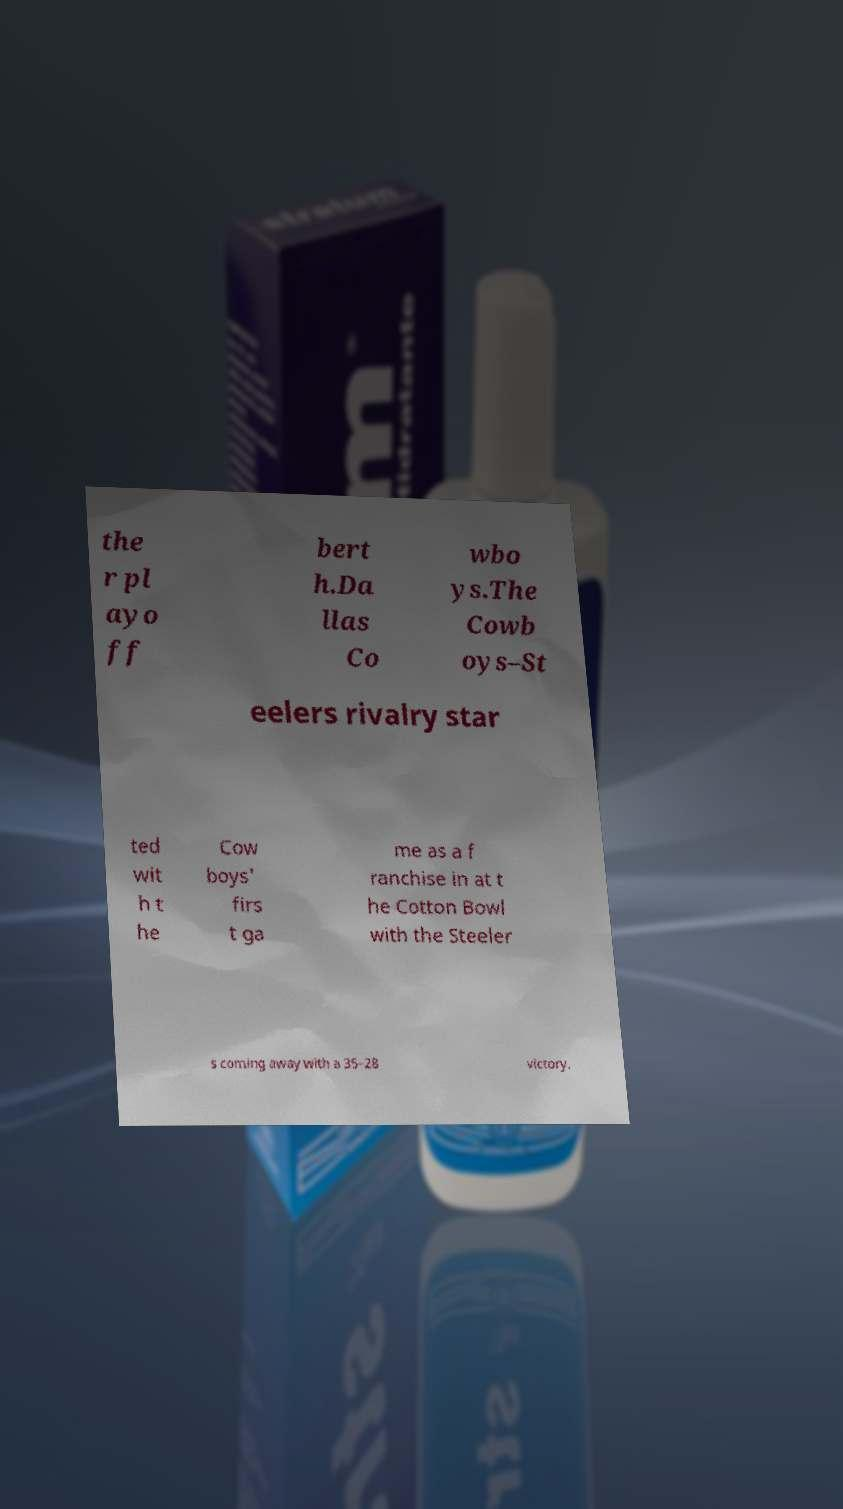I need the written content from this picture converted into text. Can you do that? the r pl ayo ff bert h.Da llas Co wbo ys.The Cowb oys–St eelers rivalry star ted wit h t he Cow boys' firs t ga me as a f ranchise in at t he Cotton Bowl with the Steeler s coming away with a 35–28 victory. 